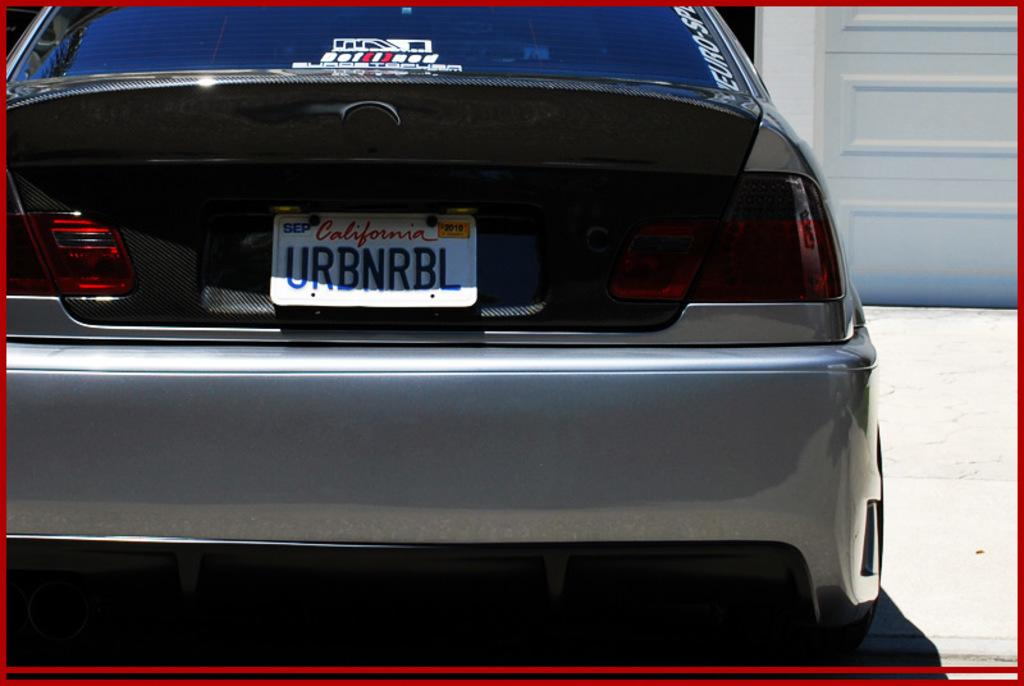<image>
Share a concise interpretation of the image provided. A car has a California license plate that reads "URBNRBL" 